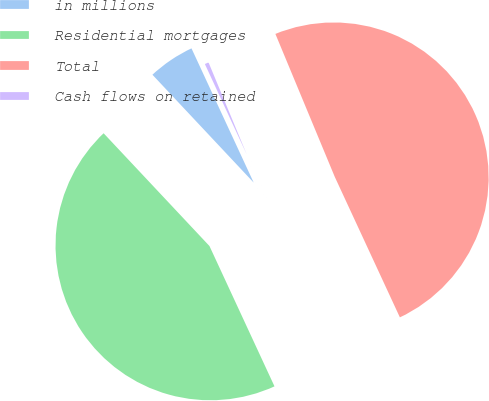<chart> <loc_0><loc_0><loc_500><loc_500><pie_chart><fcel>in millions<fcel>Residential mortgages<fcel>Total<fcel>Cash flows on retained<nl><fcel>5.09%<fcel>44.91%<fcel>49.36%<fcel>0.64%<nl></chart> 